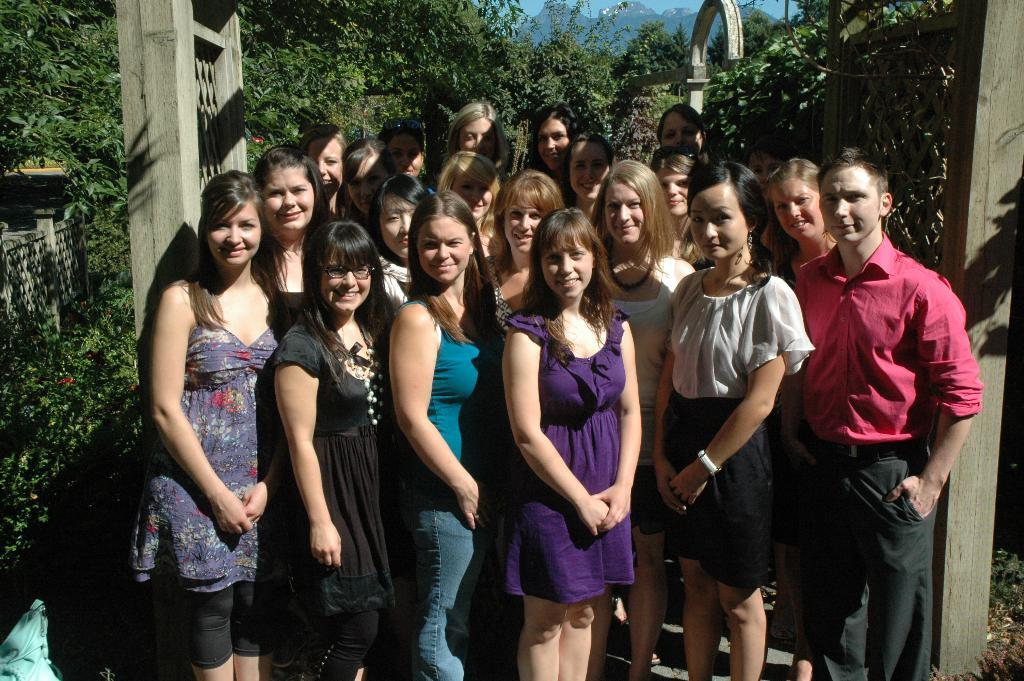How many people are in the group that is visible in the image? There is a group of people in the image, but the exact number is not specified. What are the people in the image doing? The people are standing and posing for the picture. What can be seen in the background of the image? There are trees and plants visible in the background of the image. What type of landscape is visible at the top of the image? There are mountains at the top of the image. What type of bone is visible in the image? There is no bone present in the image. How does the group of people feel about being in the picture? The image does not provide any information about the feelings or emotions of the people in the group. 